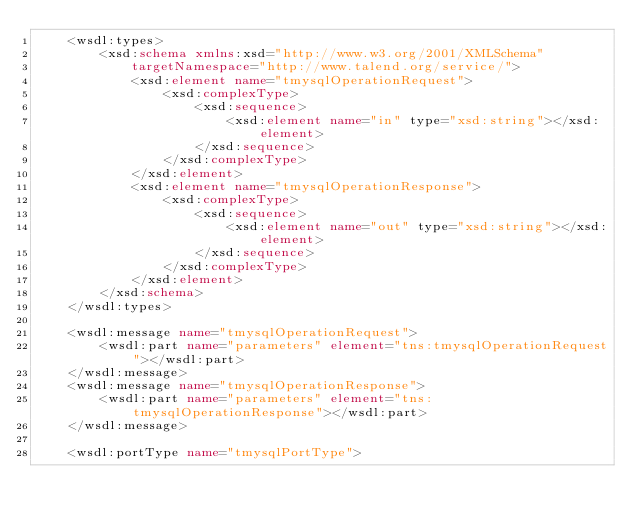<code> <loc_0><loc_0><loc_500><loc_500><_XML_>	<wsdl:types>
		<xsd:schema xmlns:xsd="http://www.w3.org/2001/XMLSchema"
			targetNamespace="http://www.talend.org/service/">
			<xsd:element name="tmysqlOperationRequest">
				<xsd:complexType>
					<xsd:sequence>
						<xsd:element name="in" type="xsd:string"></xsd:element>
					</xsd:sequence>
				</xsd:complexType>
			</xsd:element>
			<xsd:element name="tmysqlOperationResponse">
				<xsd:complexType>
					<xsd:sequence>
						<xsd:element name="out" type="xsd:string"></xsd:element>
					</xsd:sequence>
				</xsd:complexType>
			</xsd:element>
		</xsd:schema>
	</wsdl:types>

	<wsdl:message name="tmysqlOperationRequest">
		<wsdl:part name="parameters" element="tns:tmysqlOperationRequest"></wsdl:part>
	</wsdl:message>
	<wsdl:message name="tmysqlOperationResponse">
		<wsdl:part name="parameters" element="tns:tmysqlOperationResponse"></wsdl:part>
	</wsdl:message>

	<wsdl:portType name="tmysqlPortType"></code> 